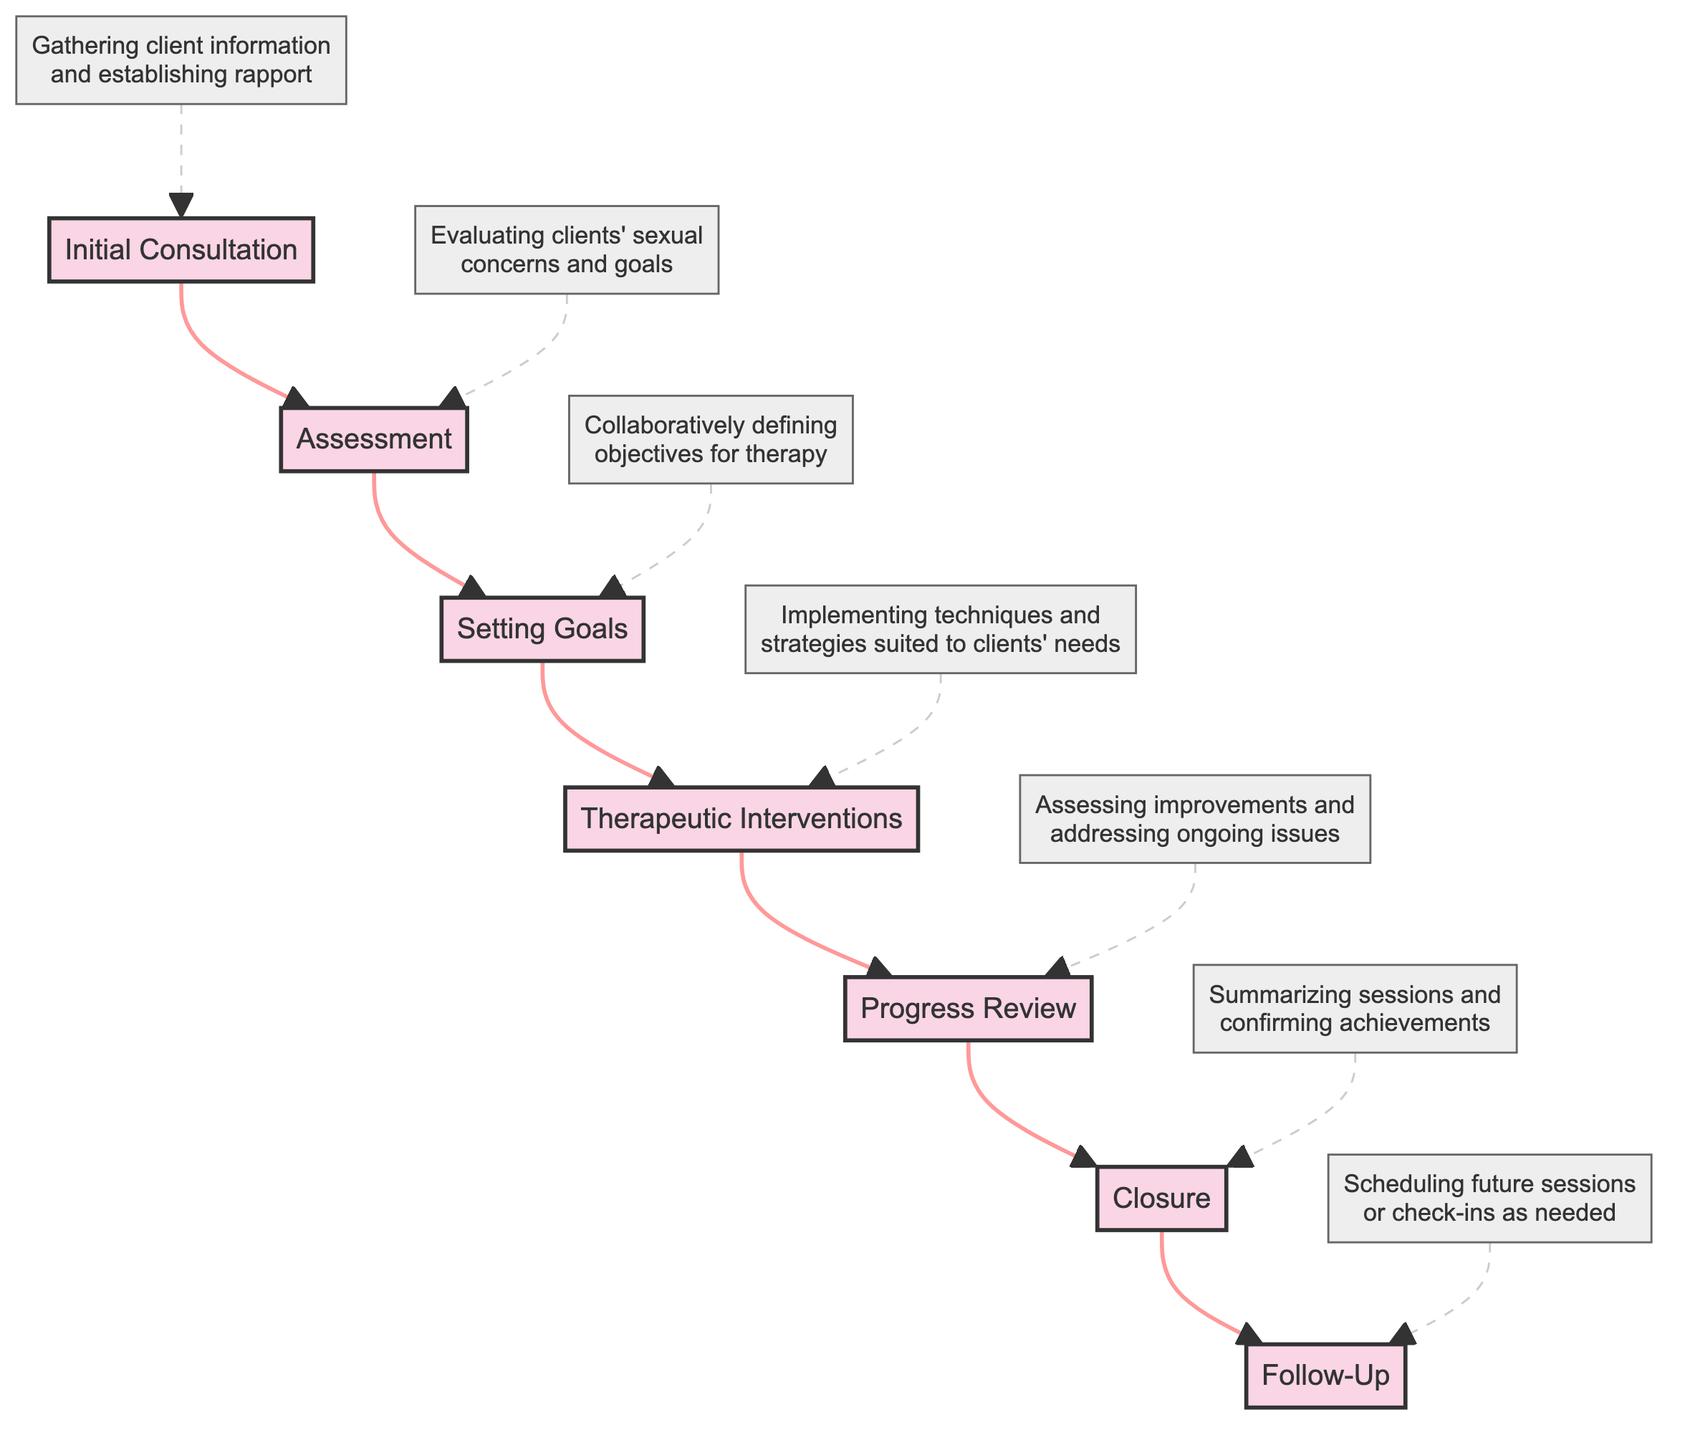What is the first stage of a sexual therapy session? The first stage listed in the diagram is "Initial Consultation." This is indicated by the top node of the flow chart.
Answer: Initial Consultation How many stages are there in the therapy session flow? By counting the nodes in the flow chart, there are a total of seven stages, from "Initial Consultation" to "Follow-Up."
Answer: 7 What is the last stage of the process? "Follow-Up" is the last stage in the diagram, which can be found at the bottom node.
Answer: Follow-Up Which stage comes immediately after Assessment? The stage that comes immediately after "Assessment" is "Setting Goals," as indicated by the directed flow from B to C in the flowchart.
Answer: Setting Goals What technique is implemented during the Therapeutic Interventions stage? During the "Therapeutic Interventions" stage, the diagram specifies that it involves "Implementing techniques and strategies suited to clients' needs." This description links directly to the node for that stage.
Answer: Implementing techniques and strategies suited to clients' needs How does the Progress Review connect to the Closure? "Progress Review" connects to "Closure" through a directed arrow indicating that after assessing improvements, the session moves on to summarize and confirm achievements.
Answer: By an arrow indicating flow What is the focus of the Assessment stage? The focus of the "Assessment" stage is "Evaluating clients' sexual concerns and goals," which is described in the text associated with the B node in the flowchart.
Answer: Evaluating clients' sexual concerns and goals What step precedes the Progress Review? The step that precedes "Progress Review" is "Therapeutic Interventions," as indicated by the flow moving from D to E in the diagram.
Answer: Therapeutic Interventions What is the primary aim during the Closure stage? The primary aim during "Closure" is "Summarizing sessions and confirming achievements," as mentioned in the description associated with node F.
Answer: Summarizing sessions and confirming achievements 